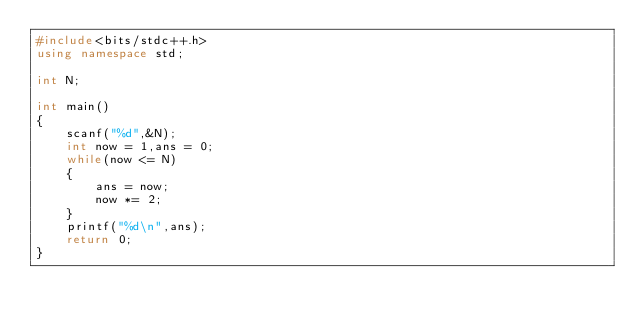Convert code to text. <code><loc_0><loc_0><loc_500><loc_500><_C++_>#include<bits/stdc++.h>
using namespace std;

int N;

int main()
{
    scanf("%d",&N);
    int now = 1,ans = 0;
    while(now <= N)
    {
        ans = now;
        now *= 2;
    }
    printf("%d\n",ans);
    return 0;
}
</code> 